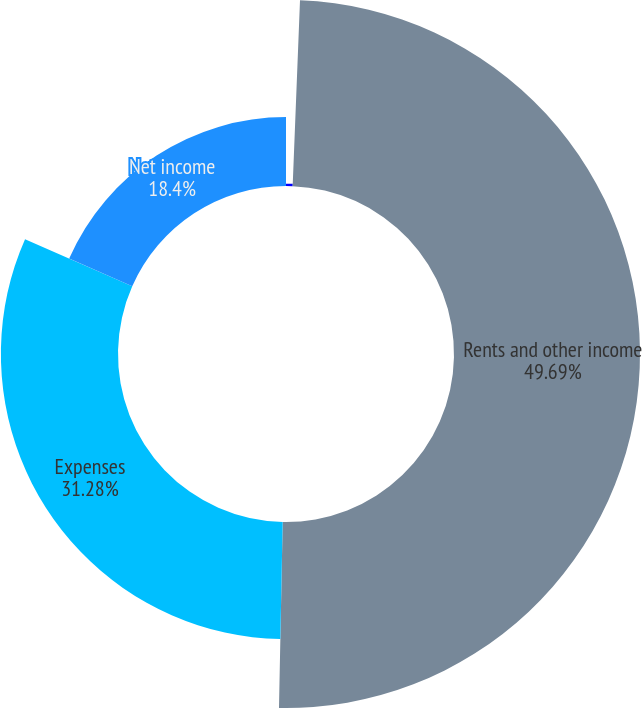<chart> <loc_0><loc_0><loc_500><loc_500><pie_chart><fcel>STATEMENTS OF INCOME<fcel>Rents and other income<fcel>Expenses<fcel>Net income<nl><fcel>0.63%<fcel>49.68%<fcel>31.28%<fcel>18.4%<nl></chart> 